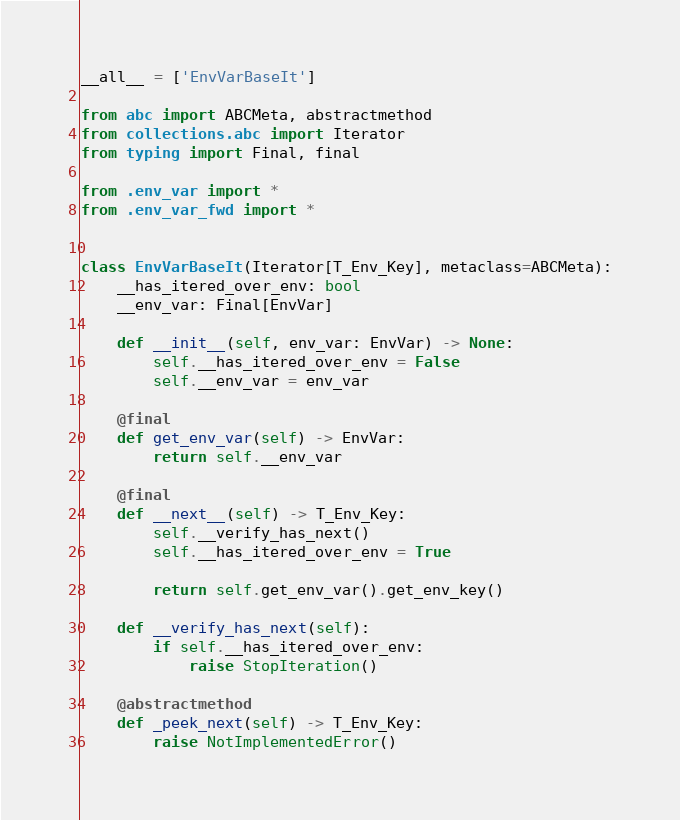<code> <loc_0><loc_0><loc_500><loc_500><_Python_>__all__ = ['EnvVarBaseIt']

from abc import ABCMeta, abstractmethod
from collections.abc import Iterator
from typing import Final, final

from .env_var import *
from .env_var_fwd import *


class EnvVarBaseIt(Iterator[T_Env_Key], metaclass=ABCMeta):
    __has_itered_over_env: bool
    __env_var: Final[EnvVar]

    def __init__(self, env_var: EnvVar) -> None:
        self.__has_itered_over_env = False
        self.__env_var = env_var

    @final
    def get_env_var(self) -> EnvVar:
        return self.__env_var

    @final
    def __next__(self) -> T_Env_Key:
        self.__verify_has_next()
        self.__has_itered_over_env = True

        return self.get_env_var().get_env_key()

    def __verify_has_next(self):
        if self.__has_itered_over_env:
            raise StopIteration()

    @abstractmethod
    def _peek_next(self) -> T_Env_Key:
        raise NotImplementedError()
</code> 